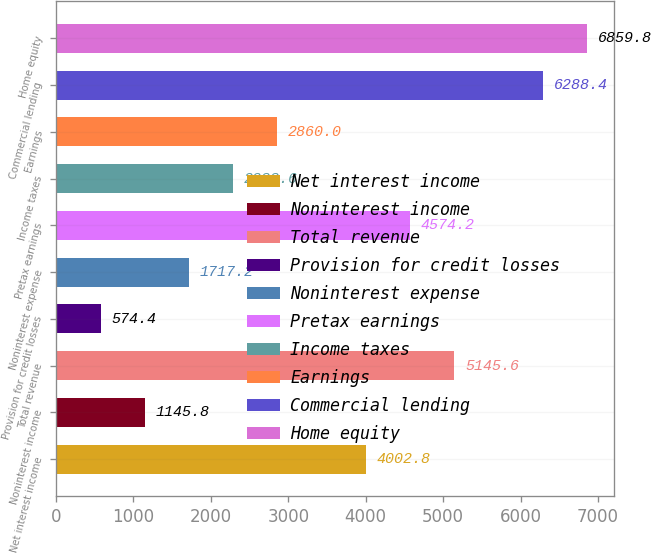Convert chart. <chart><loc_0><loc_0><loc_500><loc_500><bar_chart><fcel>Net interest income<fcel>Noninterest income<fcel>Total revenue<fcel>Provision for credit losses<fcel>Noninterest expense<fcel>Pretax earnings<fcel>Income taxes<fcel>Earnings<fcel>Commercial lending<fcel>Home equity<nl><fcel>4002.8<fcel>1145.8<fcel>5145.6<fcel>574.4<fcel>1717.2<fcel>4574.2<fcel>2288.6<fcel>2860<fcel>6288.4<fcel>6859.8<nl></chart> 